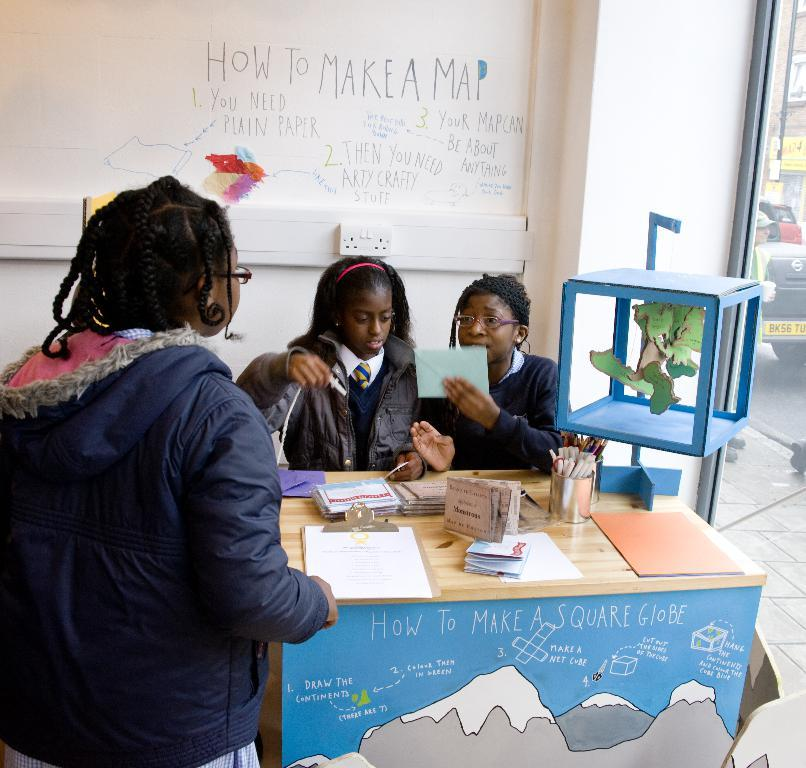How many people are in the image? There are three persons in the image. What are the positions of the people in the image? Two of the persons are sitting, and one person is standing. What objects are on the table in the image? There are papers and pens on a table. What can be seen in the background of the image? There is a wall in the background of the image. What level of expertise does the beginner have in the image? There is no indication of any expertise or skill level in the image, as it only shows three people, their positions, and objects on a table. --- Facts: 1. There is a car in the image. 2. The car is red. 3. The car has four wheels. 4. There is a road in the image. 5. The road is paved. Absurd Topics: parrot, ocean, mountain Conversation: What is the main subject of the image? The main subject of the image is a car. What color is the car? The car is red. How many wheels does the car have? The car has four wheels. What type of surface is visible in the image? There is a road in the image, and it is paved. Reasoning: Let's think step by step in order to produce the conversation. We start by identifying the main subject of the image, which is the car. Then, we describe the car's color and the number of wheels it has. Next, we mention the type of surface visible in the image, which is a paved road. Absurd Question/Answer: Can you see a parrot flying over the ocean in the image? There is no parrot or ocean present in the image; it only features a red car and a paved road. 